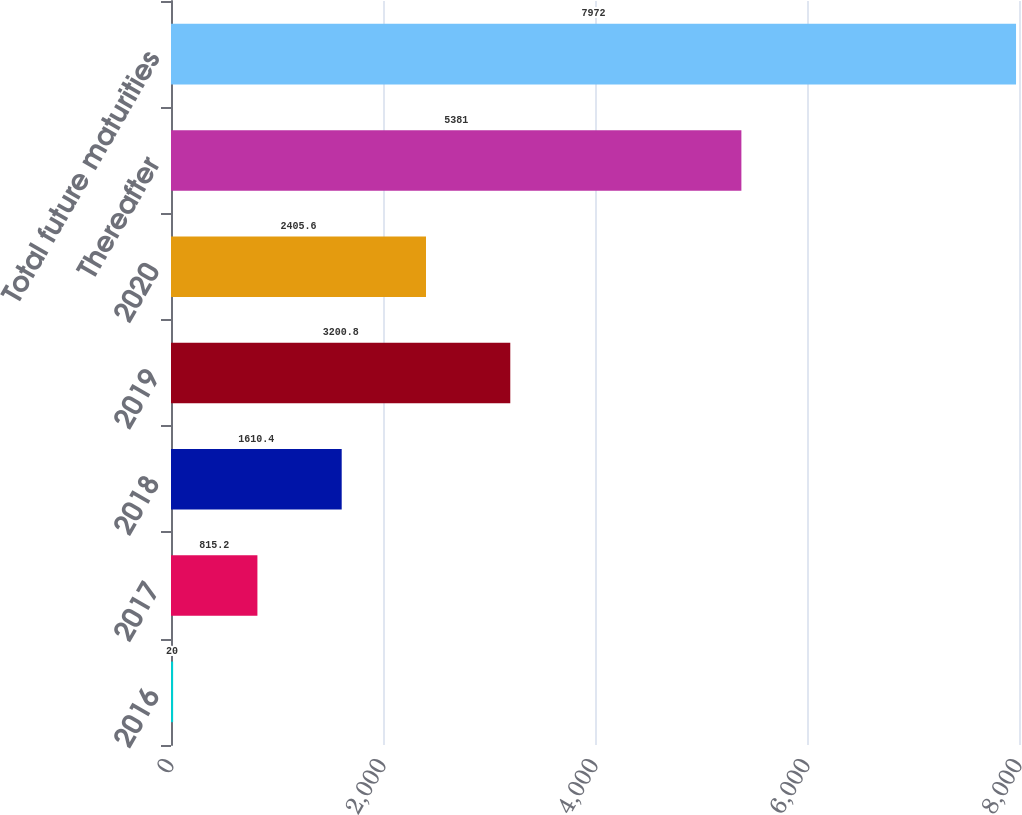Convert chart to OTSL. <chart><loc_0><loc_0><loc_500><loc_500><bar_chart><fcel>2016<fcel>2017<fcel>2018<fcel>2019<fcel>2020<fcel>Thereafter<fcel>Total future maturities<nl><fcel>20<fcel>815.2<fcel>1610.4<fcel>3200.8<fcel>2405.6<fcel>5381<fcel>7972<nl></chart> 